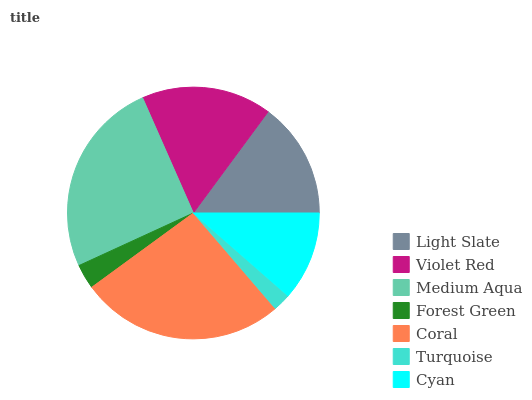Is Turquoise the minimum?
Answer yes or no. Yes. Is Coral the maximum?
Answer yes or no. Yes. Is Violet Red the minimum?
Answer yes or no. No. Is Violet Red the maximum?
Answer yes or no. No. Is Violet Red greater than Light Slate?
Answer yes or no. Yes. Is Light Slate less than Violet Red?
Answer yes or no. Yes. Is Light Slate greater than Violet Red?
Answer yes or no. No. Is Violet Red less than Light Slate?
Answer yes or no. No. Is Light Slate the high median?
Answer yes or no. Yes. Is Light Slate the low median?
Answer yes or no. Yes. Is Medium Aqua the high median?
Answer yes or no. No. Is Medium Aqua the low median?
Answer yes or no. No. 